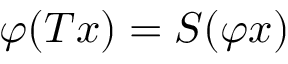<formula> <loc_0><loc_0><loc_500><loc_500>\varphi ( T x ) = S ( \varphi x )</formula> 